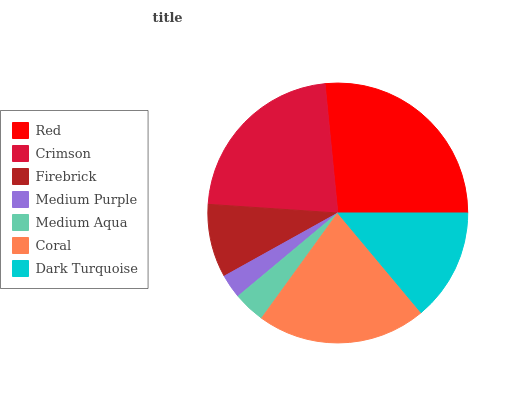Is Medium Purple the minimum?
Answer yes or no. Yes. Is Red the maximum?
Answer yes or no. Yes. Is Crimson the minimum?
Answer yes or no. No. Is Crimson the maximum?
Answer yes or no. No. Is Red greater than Crimson?
Answer yes or no. Yes. Is Crimson less than Red?
Answer yes or no. Yes. Is Crimson greater than Red?
Answer yes or no. No. Is Red less than Crimson?
Answer yes or no. No. Is Dark Turquoise the high median?
Answer yes or no. Yes. Is Dark Turquoise the low median?
Answer yes or no. Yes. Is Medium Purple the high median?
Answer yes or no. No. Is Medium Purple the low median?
Answer yes or no. No. 